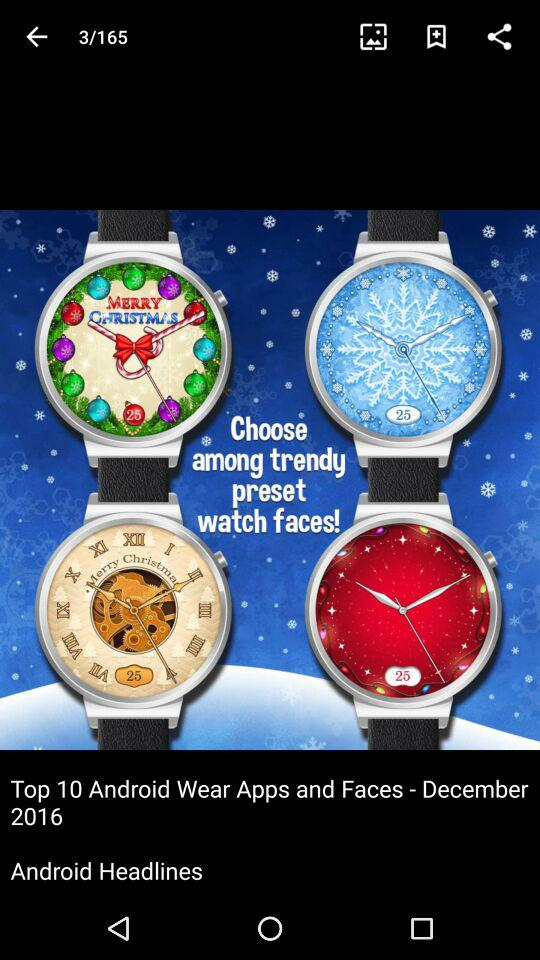What are the total images shown on the screen? There are a total of 165 images. 